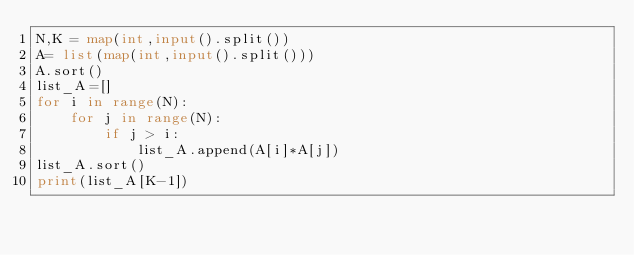<code> <loc_0><loc_0><loc_500><loc_500><_Python_>N,K = map(int,input().split())
A= list(map(int,input().split()))
A.sort()
list_A=[]
for i in range(N):
    for j in range(N):
        if j > i:
            list_A.append(A[i]*A[j])
list_A.sort()
print(list_A[K-1])</code> 